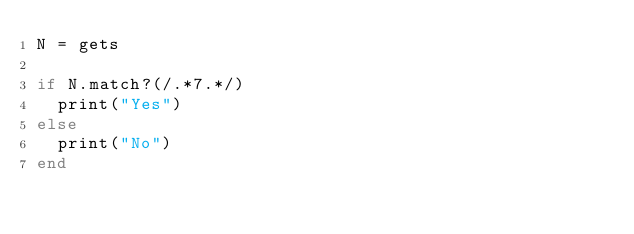Convert code to text. <code><loc_0><loc_0><loc_500><loc_500><_Ruby_>N = gets

if N.match?(/.*7.*/)
  print("Yes")
else
  print("No")
end
</code> 